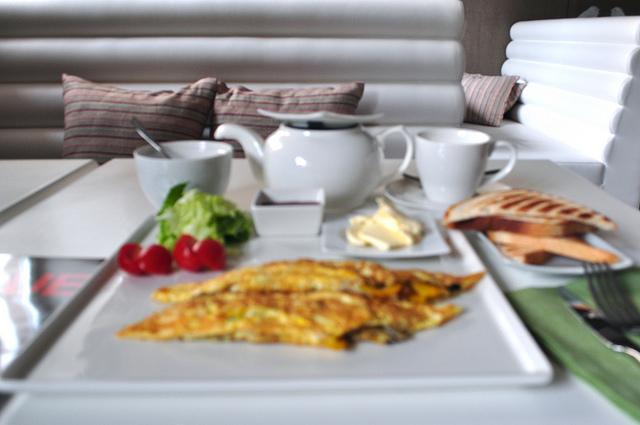How many pizzas can be seen?
Give a very brief answer. 2. How many cups can you see?
Give a very brief answer. 2. How many bowls can be seen?
Give a very brief answer. 2. 